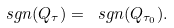<formula> <loc_0><loc_0><loc_500><loc_500>\ s g n ( Q _ { \tau } ) = \ s g n ( Q _ { \tau _ { 0 } } ) .</formula> 